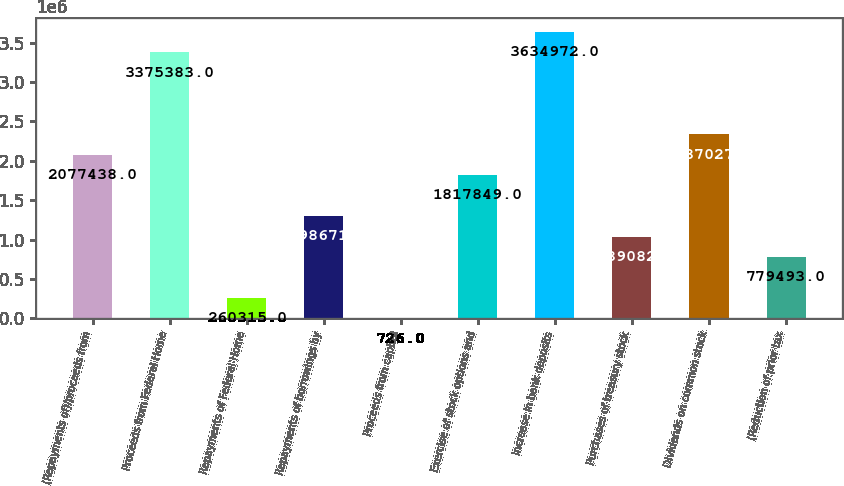Convert chart. <chart><loc_0><loc_0><loc_500><loc_500><bar_chart><fcel>(Repayments of)/proceeds from<fcel>Proceeds from Federal Home<fcel>Repayments of Federal Home<fcel>Repayments of borrowings by<fcel>Proceeds from capital<fcel>Exercise of stock options and<fcel>Increase in bank deposits<fcel>Purchases of treasury stock<fcel>Dividends on common stock<fcel>(Reduction of prior tax<nl><fcel>2.07744e+06<fcel>3.37538e+06<fcel>260315<fcel>1.29867e+06<fcel>726<fcel>1.81785e+06<fcel>3.63497e+06<fcel>1.03908e+06<fcel>2.33703e+06<fcel>779493<nl></chart> 